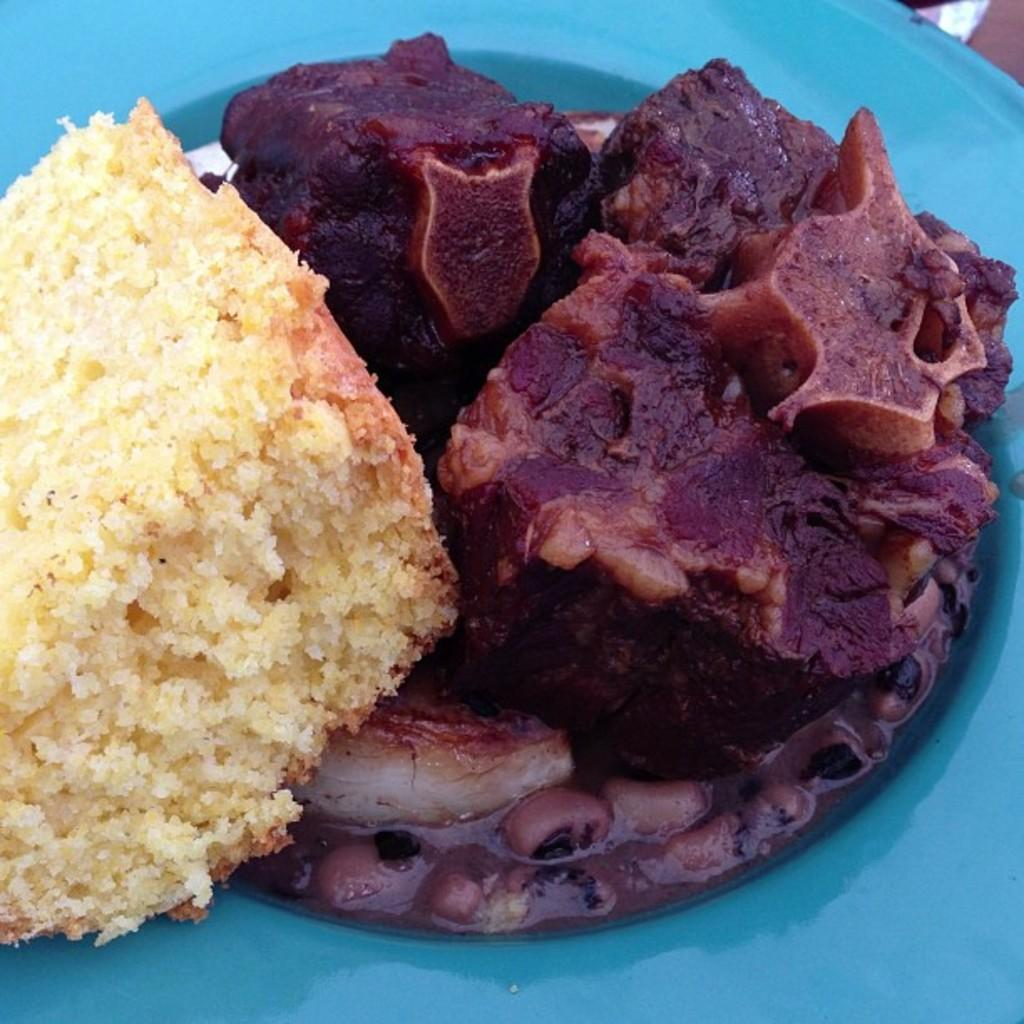What type of food can be seen in the image? There is food in the image, including meat and bread pieces. How is the food arranged in the image? The food is on a plate in the image. What is the condition of the stick in the image? There is no stick present in the image. 